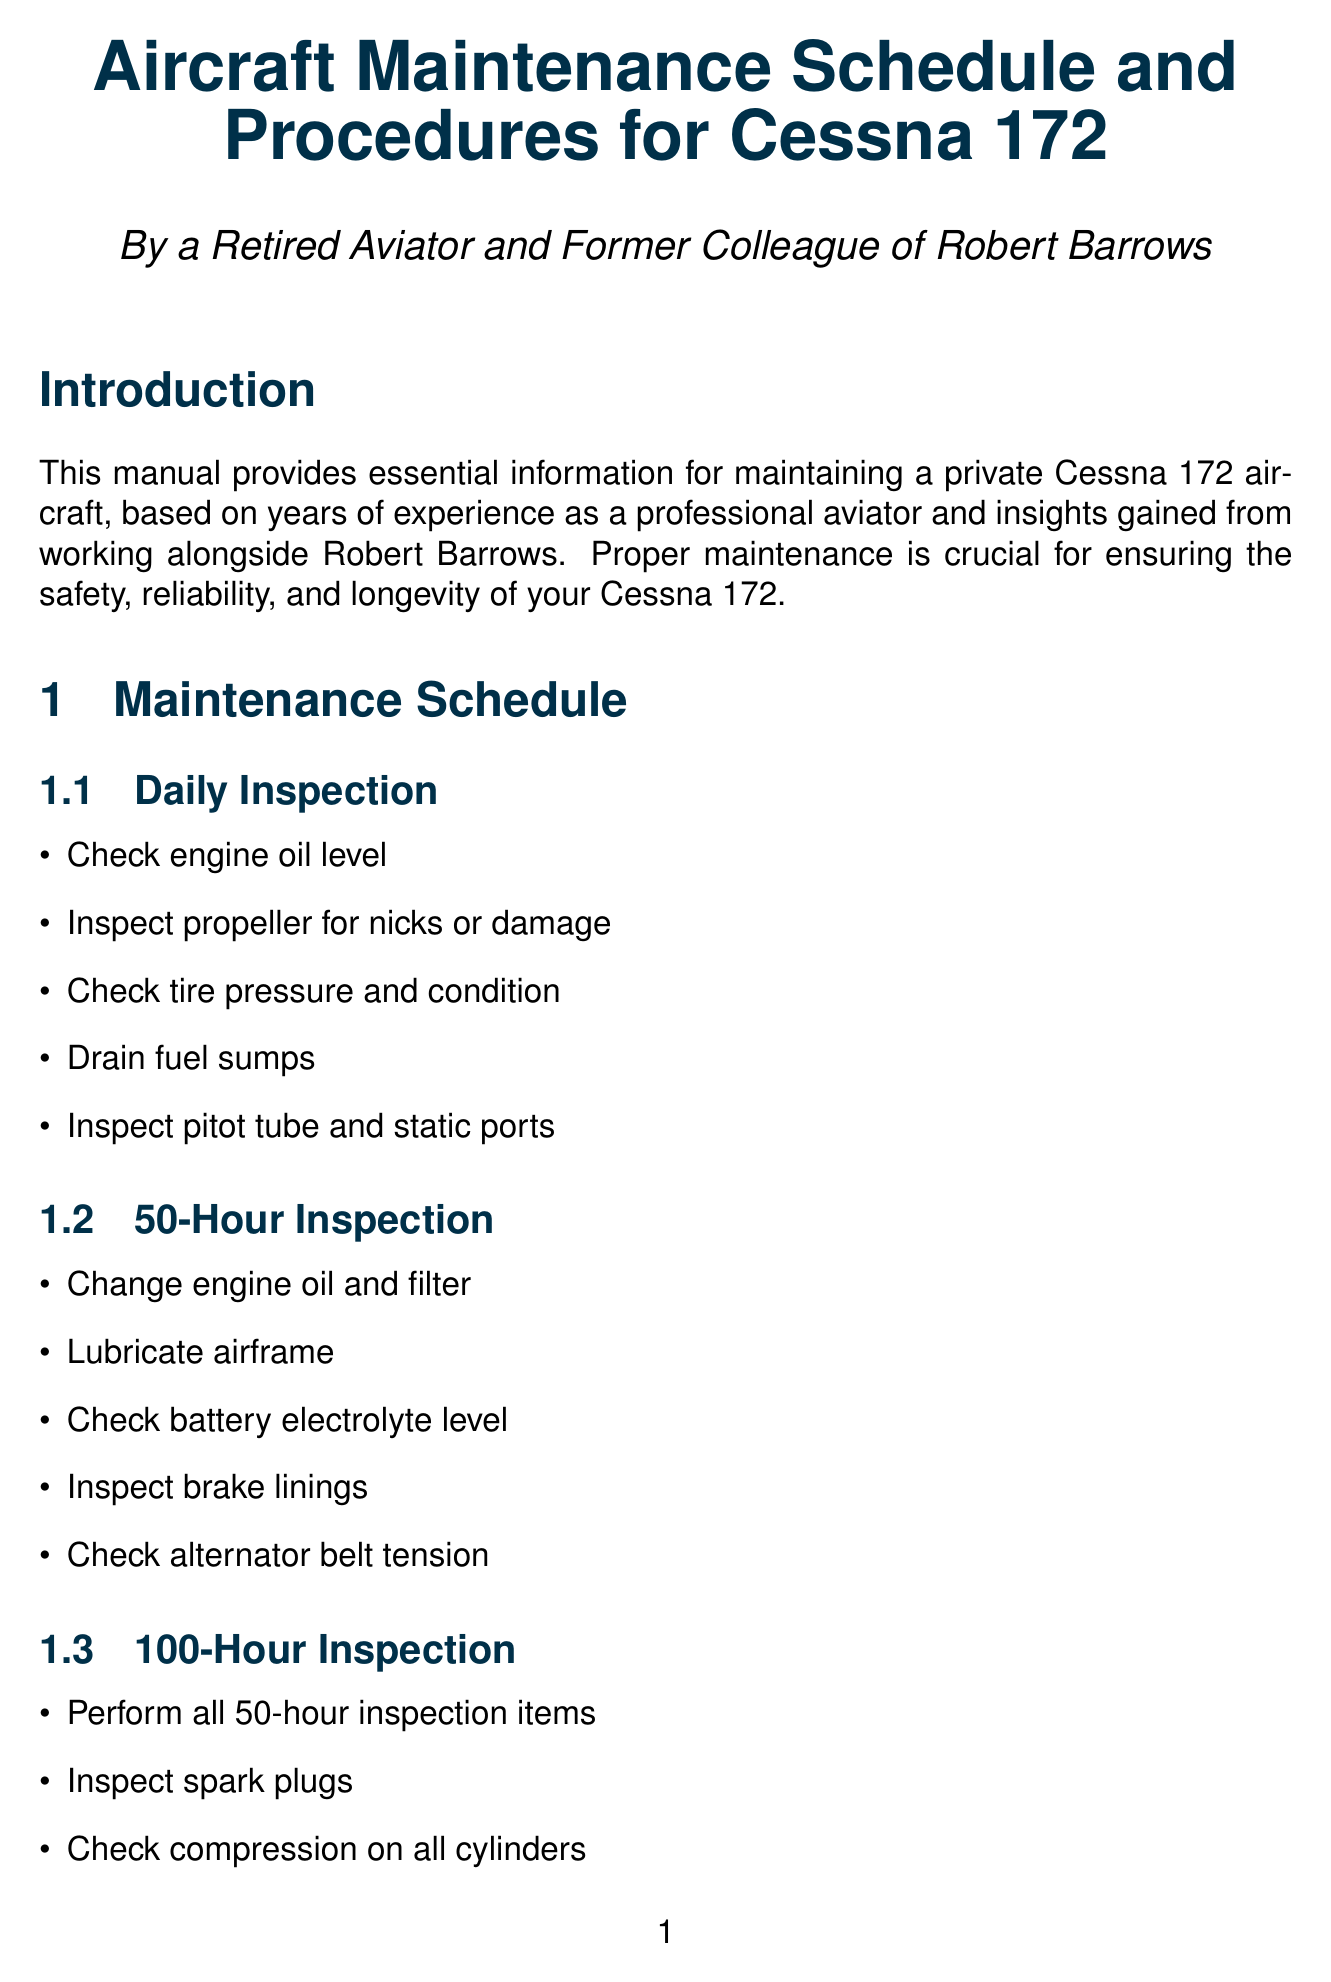what is the manual title? The title of the manual is the first section in the document, which provides an overview of its purpose.
Answer: Aircraft Maintenance Schedule and Procedures for Cessna 172 how many inspections are listed in the maintenance schedule? The maintenance schedule contains four distinct inspection types.
Answer: 4 what is the model of the engine used in the Cessna 172? The engine model is specified in the key components section related to the engine.
Answer: Lycoming O-320 what should be checked during the daily inspection? One of the daily inspection items is highlighted under the section dedicated to daily maintenance checks.
Answer: Engine oil level which software solution is recommended for record keeping? The digital solutions section suggests a specific type of software for easier management of maintenance records.
Answer: MyAircraftLogs what is emphasized in the personal insights section? The author shares important advice related to maintenance practices based on personal experience, noted in the personal insights section.
Answer: Pre-flight inspections how often should the brake linings be inspected? The frequency for inspecting brake linings is indicated under a specific inspection schedule noted in the maintenance schedule section.
Answer: 50 hours what is the primary importance of maintaining accurate records? The importance of record keeping is stated clearly in a specific section of the document.
Answer: Regulatory compliance and resale value what equipment should be used for cylinder inspections? The tools section lists specific equipment recommended for various maintenance tasks associated with the aircraft.
Answer: Borescope 